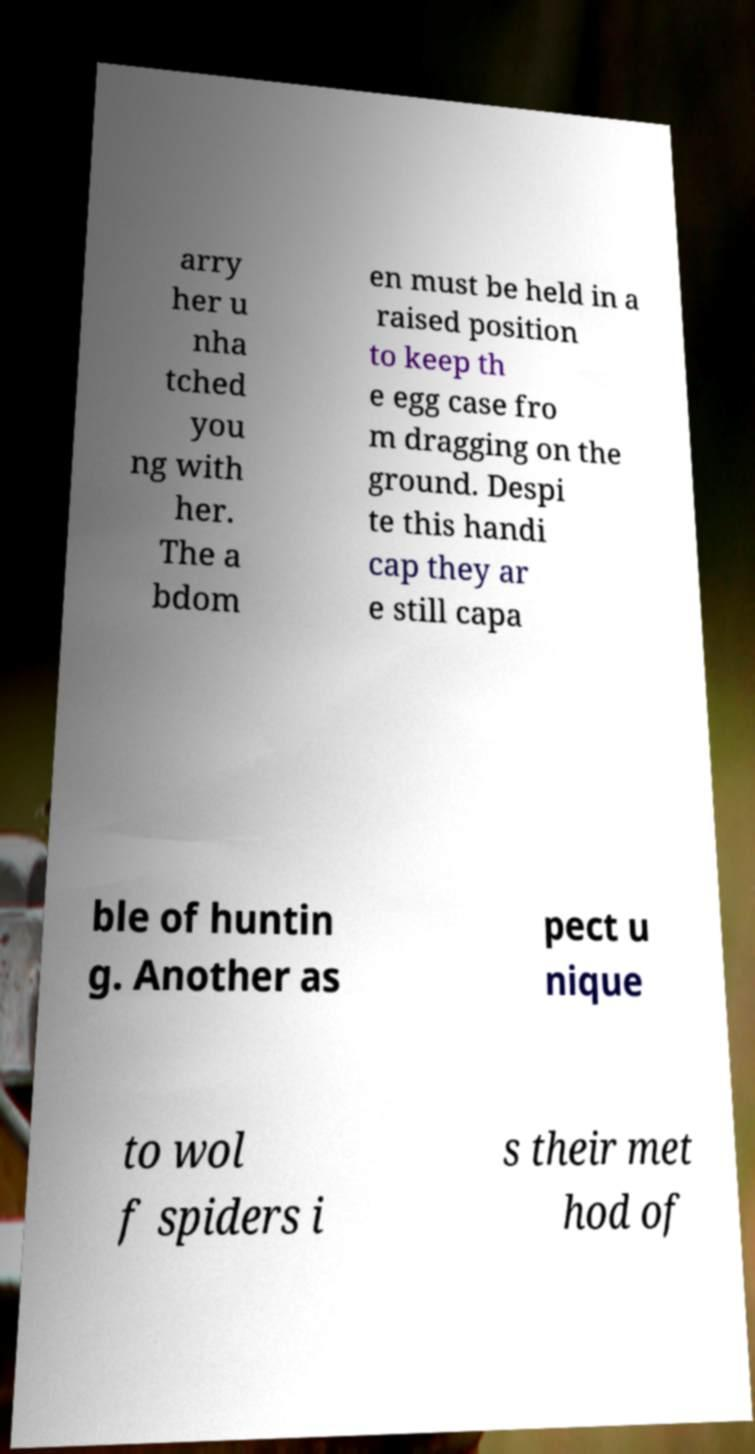What messages or text are displayed in this image? I need them in a readable, typed format. arry her u nha tched you ng with her. The a bdom en must be held in a raised position to keep th e egg case fro m dragging on the ground. Despi te this handi cap they ar e still capa ble of huntin g. Another as pect u nique to wol f spiders i s their met hod of 